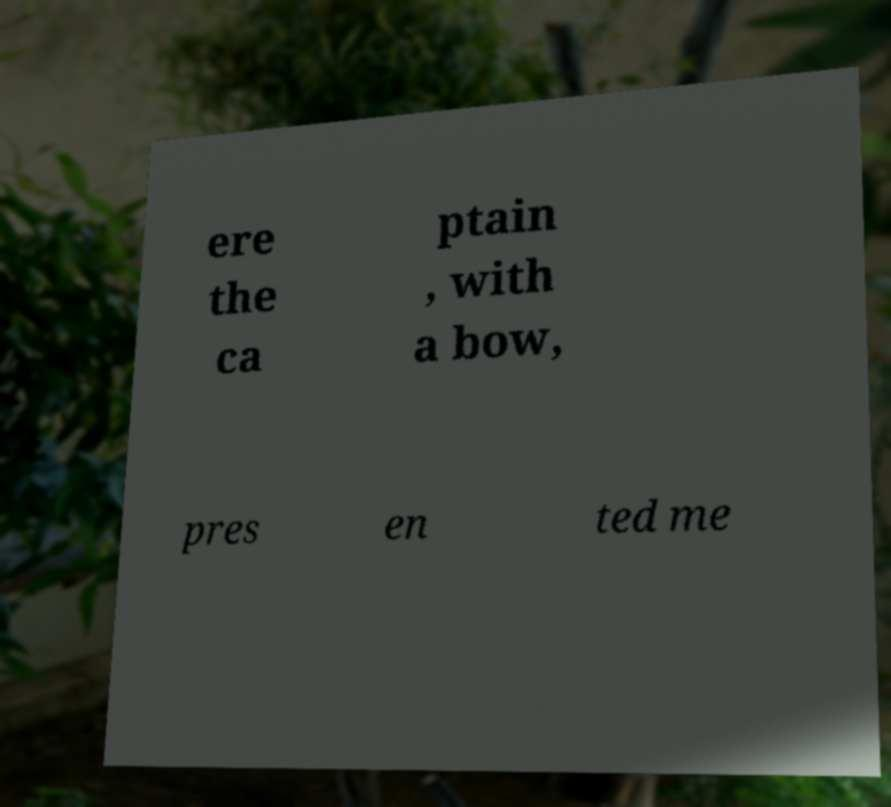Can you accurately transcribe the text from the provided image for me? ere the ca ptain , with a bow, pres en ted me 